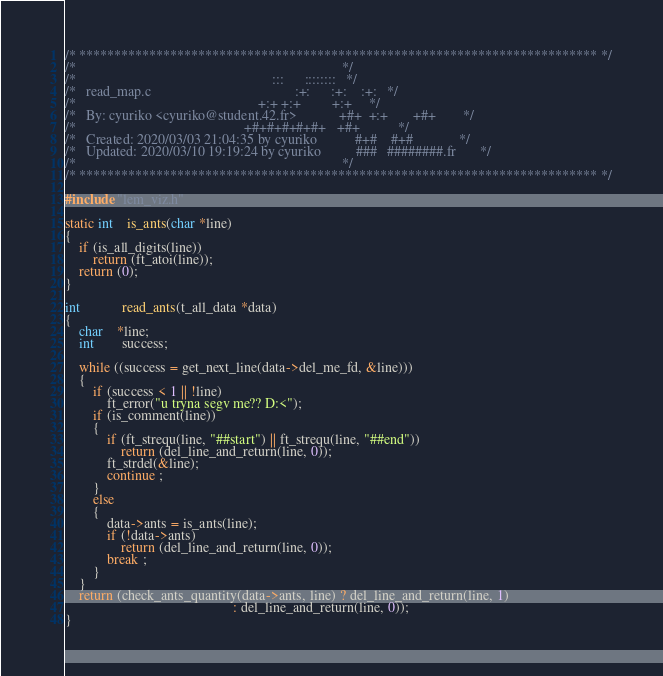<code> <loc_0><loc_0><loc_500><loc_500><_C_>/* ************************************************************************** */
/*                                                                            */
/*                                                        :::      ::::::::   */
/*   read_map.c                                         :+:      :+:    :+:   */
/*                                                    +:+ +:+         +:+     */
/*   By: cyuriko <cyuriko@student.42.fr>            +#+  +:+       +#+        */
/*                                                +#+#+#+#+#+   +#+           */
/*   Created: 2020/03/03 21:04:35 by cyuriko           #+#    #+#             */
/*   Updated: 2020/03/10 19:19:24 by cyuriko          ###   ########.fr       */
/*                                                                            */
/* ************************************************************************** */

#include "lem_viz.h"

static int	is_ants(char *line)
{
	if (is_all_digits(line))
		return (ft_atoi(line));
	return (0);
}

int			read_ants(t_all_data *data)
{
	char	*line;
	int		success;

	while ((success = get_next_line(data->del_me_fd, &line)))
	{
		if (success < 1 || !line)
			ft_error("u tryna segv me?? D:<");
		if (is_comment(line))
		{
			if (ft_strequ(line, "##start") || ft_strequ(line, "##end"))
				return (del_line_and_return(line, 0));
			ft_strdel(&line);
			continue ;
		}
		else
		{
			data->ants = is_ants(line);
			if (!data->ants)
				return (del_line_and_return(line, 0));
			break ;
		}
	}
	return (check_ants_quantity(data->ants, line) ? del_line_and_return(line, 1)
												: del_line_and_return(line, 0));
}
</code> 